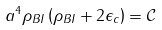<formula> <loc_0><loc_0><loc_500><loc_500>a ^ { 4 } \rho _ { B I } \left ( \rho _ { B I } + 2 \epsilon _ { c } \right ) = \mathcal { C }</formula> 